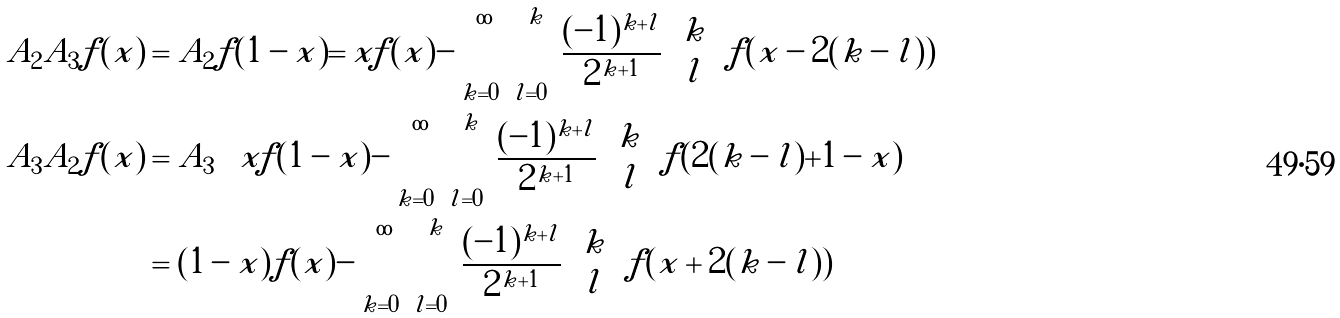Convert formula to latex. <formula><loc_0><loc_0><loc_500><loc_500>A _ { 2 } A _ { 3 } f ( x ) & = A _ { 2 } f ( 1 - x ) = x f ( x ) - \sum _ { k = 0 } ^ { \infty } \sum _ { l = 0 } ^ { k } \frac { ( - 1 ) ^ { k + l } } { 2 ^ { k + 1 } } \binom { k } { l } f ( x - 2 ( k - l ) ) \\ A _ { 3 } A _ { 2 } f ( x ) & = A _ { 3 } \left ( x f ( 1 - x ) - \sum _ { k = 0 } ^ { \infty } \sum _ { l = 0 } ^ { k } \frac { ( - 1 ) ^ { k + l } } { 2 ^ { k + 1 } } \binom { k } { l } f ( 2 ( k - l ) + 1 - x ) \right ) \\ & = ( 1 - x ) f ( x ) - \sum _ { k = 0 } ^ { \infty } \sum _ { l = 0 } ^ { k } \frac { ( - 1 ) ^ { k + l } } { 2 ^ { k + 1 } } \binom { k } { l } f ( x + 2 ( k - l ) )</formula> 